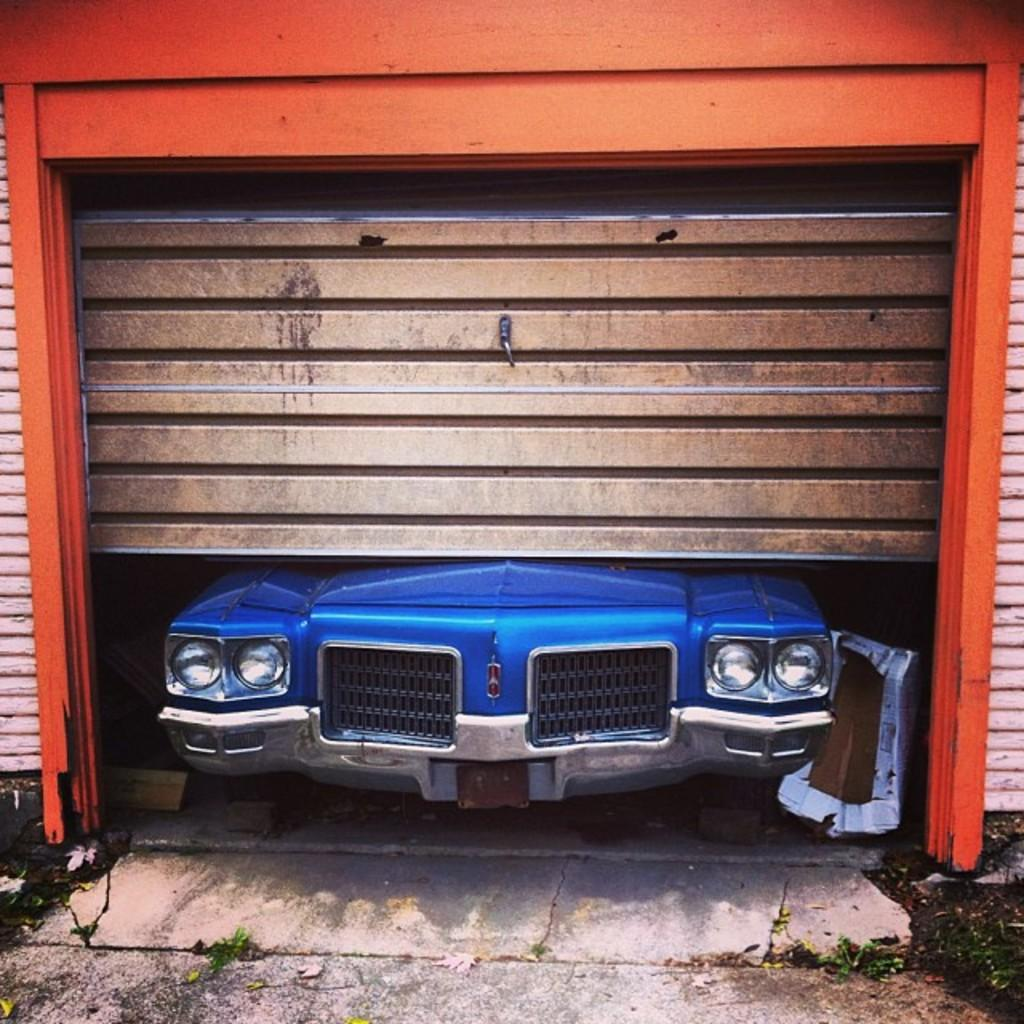What type of structure is visible in the image? There is a house in the image. Can you describe the interior of the house? There is a vehicle inside the house. What type of rule is being enforced on the stage in the image? There is no stage present in the image, and therefore no rule being enforced. What type of coach is visible in the image? There is no coach present in the image. 